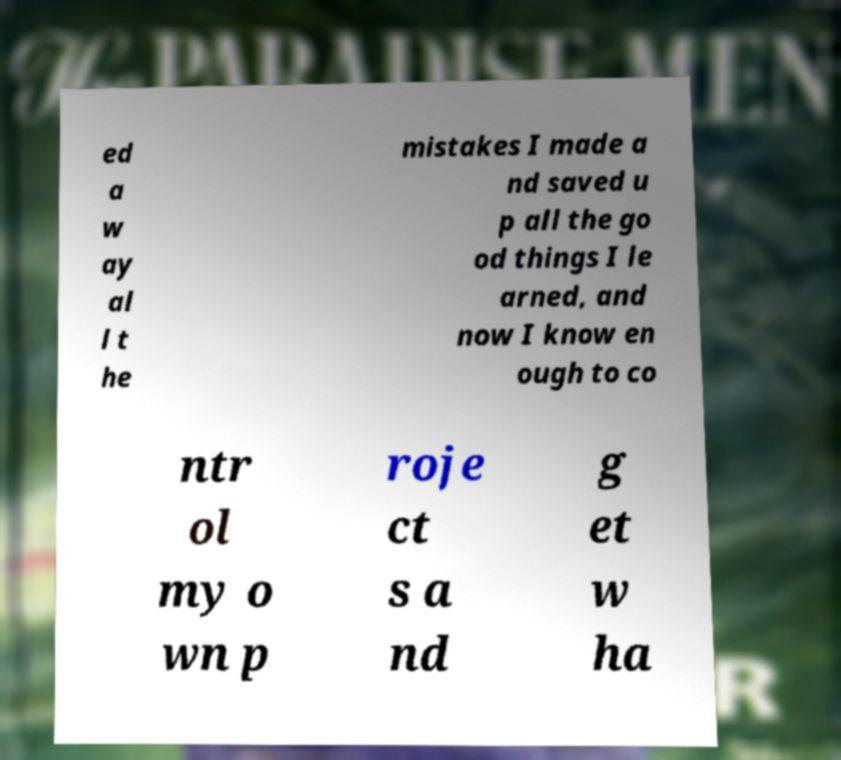Could you assist in decoding the text presented in this image and type it out clearly? ed a w ay al l t he mistakes I made a nd saved u p all the go od things I le arned, and now I know en ough to co ntr ol my o wn p roje ct s a nd g et w ha 